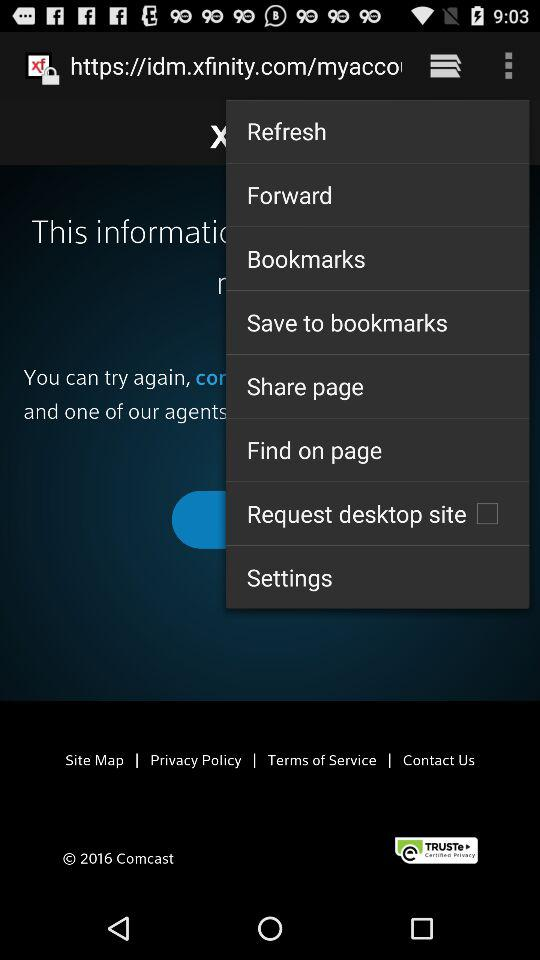What is the status of "Request desktop site"? The status is "off". 